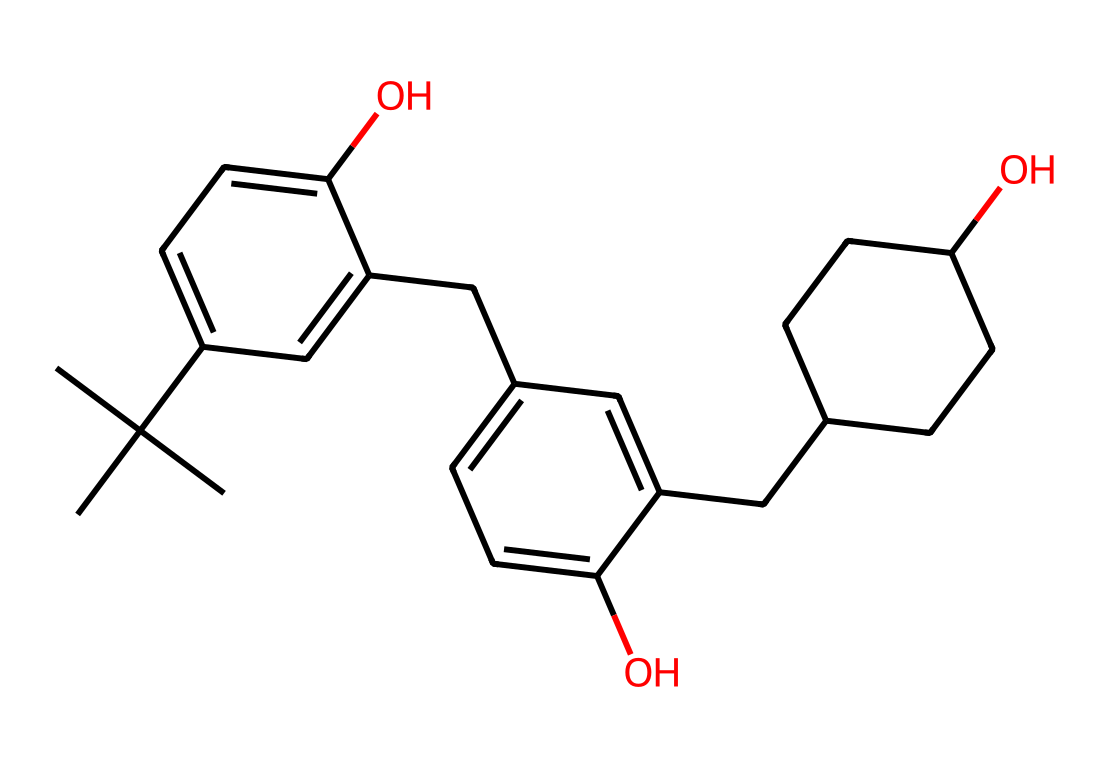What is the total number of carbon atoms in this photoresist? By examining the SMILES representation, we can count the carbon atoms; each distinct 'C' in the sequence represents a carbon atom. There are 21 carbon atoms present.
Answer: 21 How many hydroxyl (–OH) groups are present in this structure? The "O" in the SMILES corresponds to oxygen atoms in the hydroxyl groups, and the context suggests connections to carbon atom represented by preceding "c" or "C", showing that there are 2 hydroxyl groups.
Answer: 2 What is the primary functional group in this chemical? The presence of the hydroxyl groups (-OH) indicates that the primary functional group is alcohol. This contributes to the photoresist properties by modulating its reactivity to light.
Answer: alcohol Does this photoresist contain any aromatic rings? The chemical structure has multiple 'c' (aromatic carbon) and 'c' that indicates connecting aromatic carbons, confirming the presence of aromatic rings due to the cyclic nature of those components.
Answer: yes What type of polymerization is likely involved in the curing process of this photoresist? Given the presence of alcoholic hydroxyl groups and the probable formation of crosslinks, it indicates that condensation polymerization is likely during the curing process, as moisture or heat can efficiently promote this.
Answer: condensation polymerization What effect do the side groups have on the photoresist's properties? The bulky side groups contribute steric hindrance and can alter the solubility and optical properties of the photoresist, enhancing its performance in 3D printing, allowing better definition of circuit features.
Answer: steric hindrance 